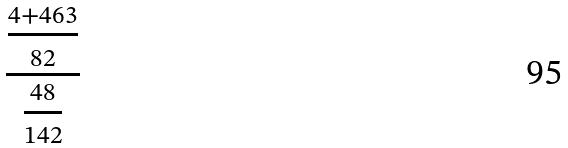<formula> <loc_0><loc_0><loc_500><loc_500>\frac { \frac { 4 + 4 6 3 } { 8 2 } } { \frac { 4 8 } { 1 4 2 } }</formula> 